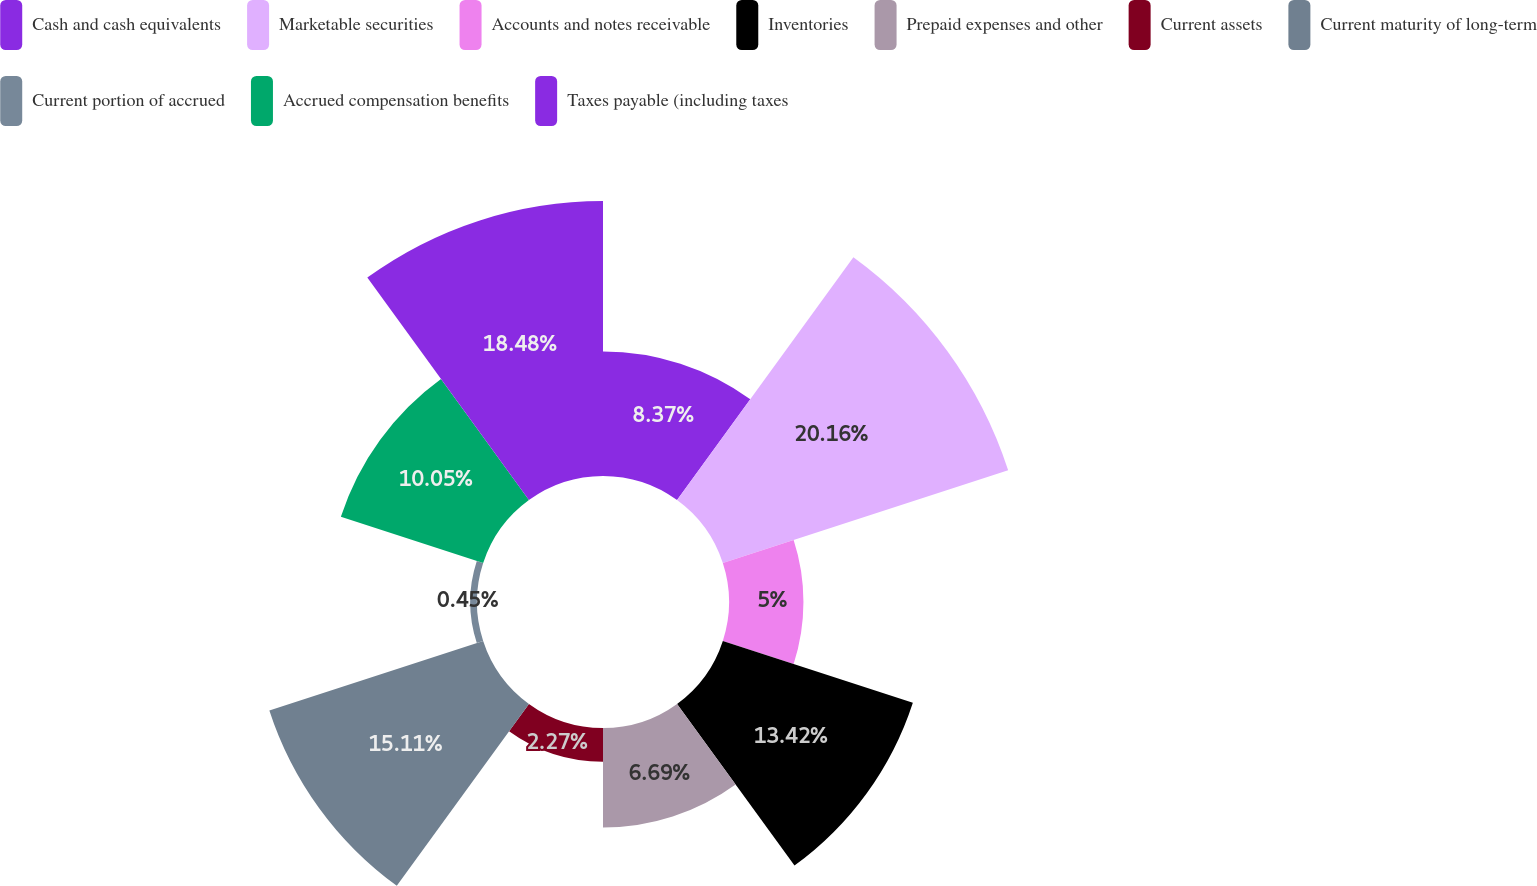<chart> <loc_0><loc_0><loc_500><loc_500><pie_chart><fcel>Cash and cash equivalents<fcel>Marketable securities<fcel>Accounts and notes receivable<fcel>Inventories<fcel>Prepaid expenses and other<fcel>Current assets<fcel>Current maturity of long-term<fcel>Current portion of accrued<fcel>Accrued compensation benefits<fcel>Taxes payable (including taxes<nl><fcel>8.37%<fcel>20.15%<fcel>5.0%<fcel>13.42%<fcel>6.69%<fcel>2.27%<fcel>15.1%<fcel>0.45%<fcel>10.05%<fcel>18.47%<nl></chart> 